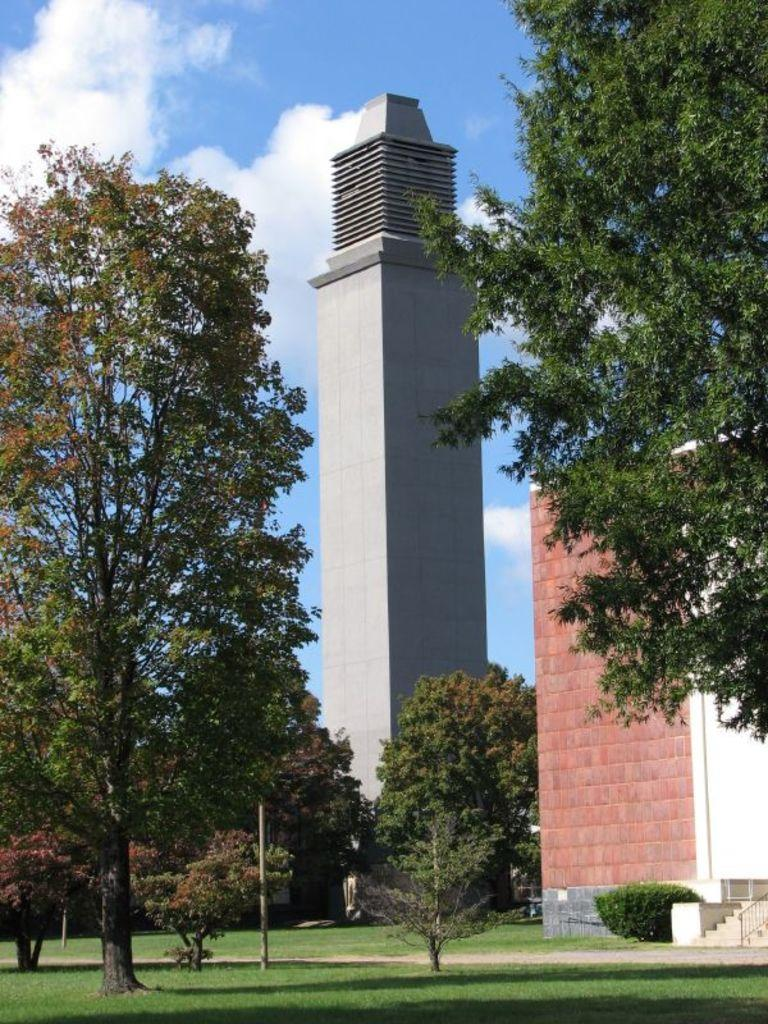What type of structures can be seen in the image? There are many buildings in the image. What type of vegetation is present in the image? There are trees in the image. What type of ground cover is present in the image? There is grass in the image. What type of juice is being served in the image? There is no juice present in the image; it only features buildings, trees, and grass. How many hens can be seen in the image? There are no hens present in the image. 